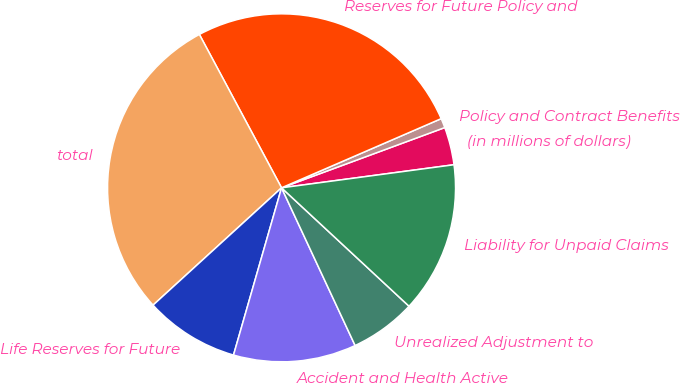Convert chart to OTSL. <chart><loc_0><loc_0><loc_500><loc_500><pie_chart><fcel>(in millions of dollars)<fcel>Policy and Contract Benefits<fcel>Reserves for Future Policy and<fcel>total<fcel>Life Reserves for Future<fcel>Accident and Health Active<fcel>Unrealized Adjustment to<fcel>Liability for Unpaid Claims<nl><fcel>3.51%<fcel>0.88%<fcel>26.32%<fcel>28.95%<fcel>8.77%<fcel>11.4%<fcel>6.14%<fcel>14.03%<nl></chart> 